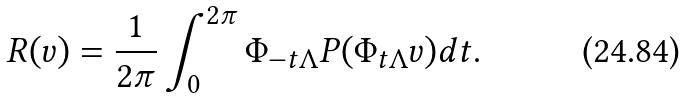<formula> <loc_0><loc_0><loc_500><loc_500>R ( v ) = \frac { 1 } { 2 \pi } \int _ { 0 } ^ { 2 \pi } \Phi _ { - t \Lambda } P ( \Phi _ { t \Lambda } v ) d t .</formula> 